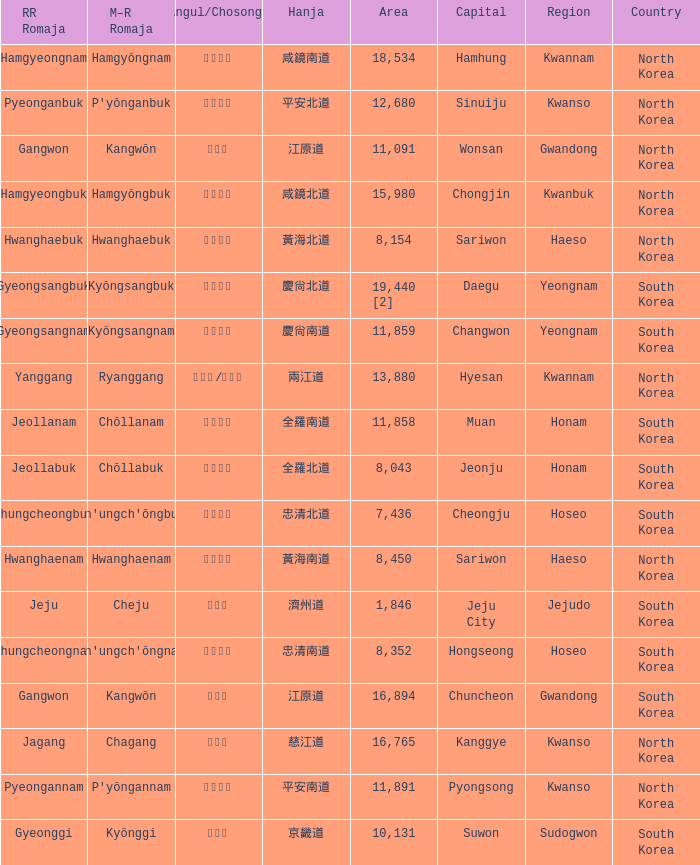Which capital has a Hangul of 경상남도? Changwon. 